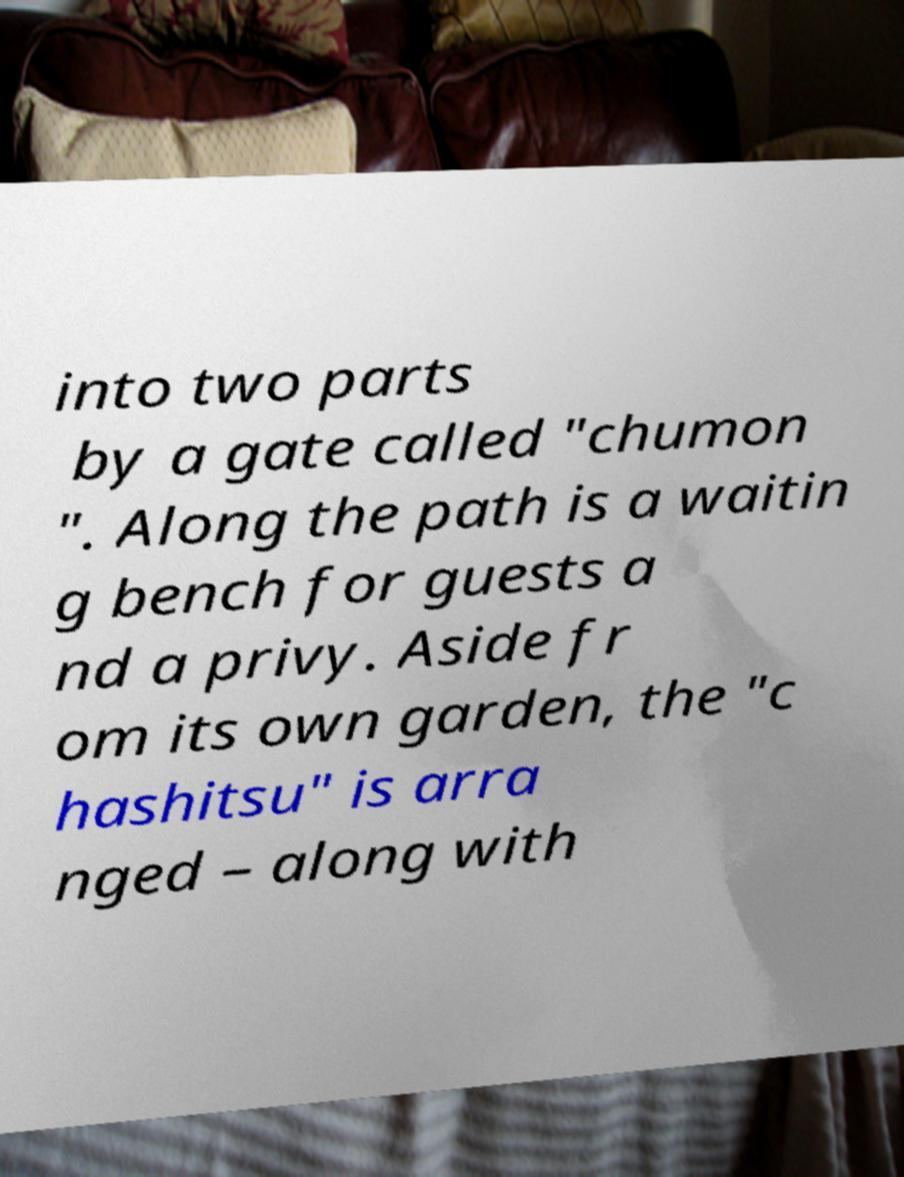What messages or text are displayed in this image? I need them in a readable, typed format. into two parts by a gate called "chumon ". Along the path is a waitin g bench for guests a nd a privy. Aside fr om its own garden, the "c hashitsu" is arra nged – along with 